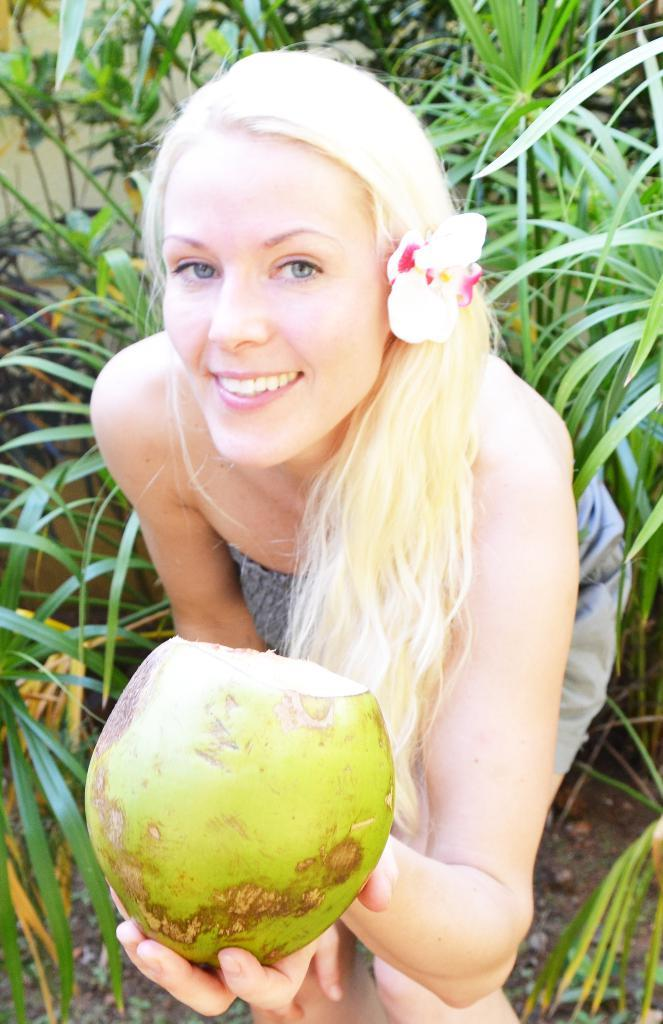Who is the main subject in the image? There is a girl in the center of the image. What is the girl holding in her hand? The girl is holding a coconut in her hand. Can you describe the surroundings in the image? There is greenery around the area of the image. What type of letter is the girl holding in her hand? The girl is not holding a letter in her hand; she is holding a coconut. How does the girl express her feelings in the image? The image does not convey the girl's feelings, so we cannot determine how she expresses them. 